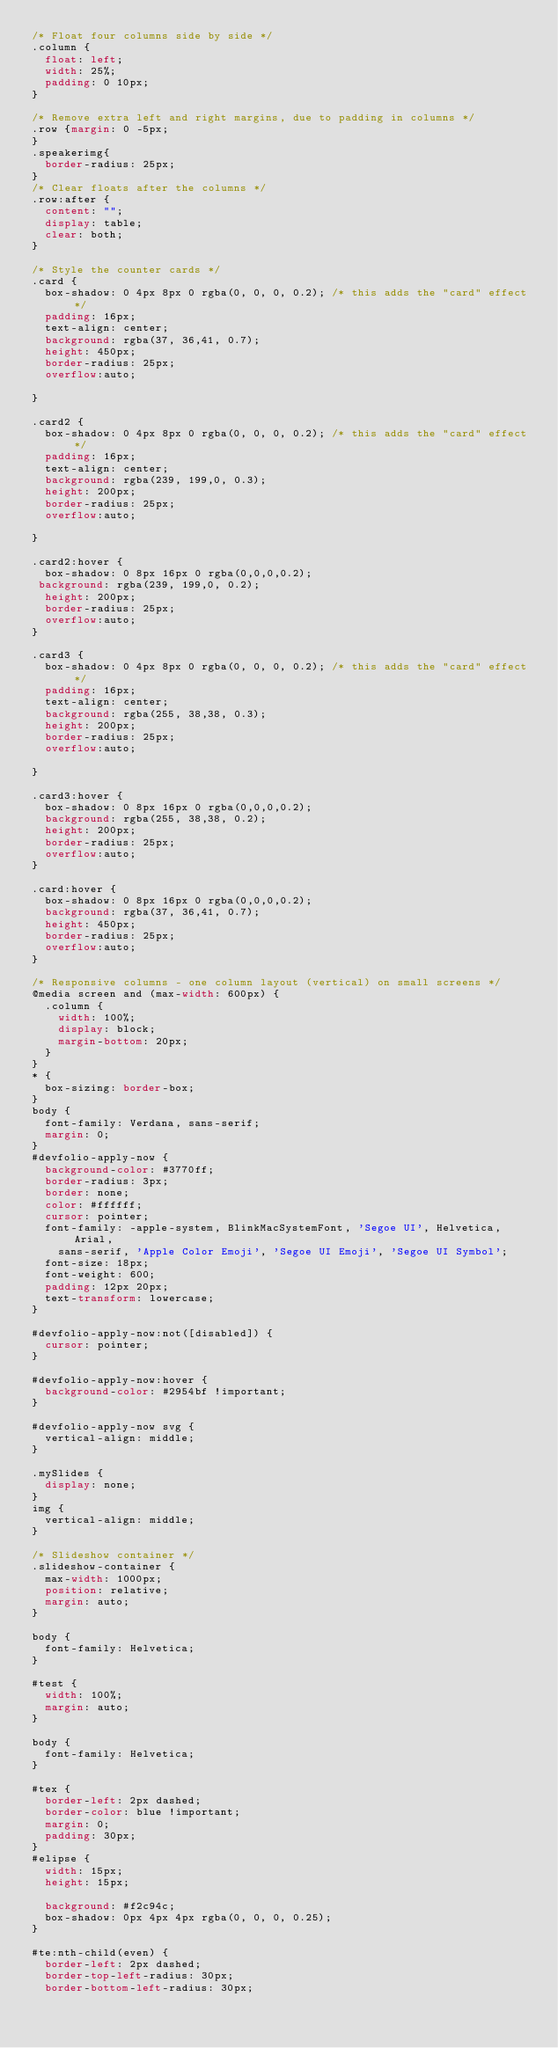Convert code to text. <code><loc_0><loc_0><loc_500><loc_500><_CSS_>/* Float four columns side by side */
.column {
  float: left;
  width: 25%;
  padding: 0 10px;
}

/* Remove extra left and right margins, due to padding in columns */
.row {margin: 0 -5px;
}
.speakerimg{
	border-radius: 25px;
}
/* Clear floats after the columns */
.row:after {
  content: "";
  display: table;
  clear: both;
}

/* Style the counter cards */
.card {
  box-shadow: 0 4px 8px 0 rgba(0, 0, 0, 0.2); /* this adds the "card" effect */
  padding: 16px;
  text-align: center;
  background: rgba(37, 36,41, 0.7);
  height: 450px;
  border-radius: 25px;
  overflow:auto;

}

.card2 {
  box-shadow: 0 4px 8px 0 rgba(0, 0, 0, 0.2); /* this adds the "card" effect */
  padding: 16px;
  text-align: center;
  background: rgba(239, 199,0, 0.3);
  height: 200px;
  border-radius: 25px;
  overflow:auto;

}

.card2:hover {
  box-shadow: 0 8px 16px 0 rgba(0,0,0,0.2);
 background: rgba(239, 199,0, 0.2);
  height: 200px;
  border-radius: 25px;
  overflow:auto;
}

.card3 {
  box-shadow: 0 4px 8px 0 rgba(0, 0, 0, 0.2); /* this adds the "card" effect */
  padding: 16px;
  text-align: center;
  background: rgba(255, 38,38, 0.3);
  height: 200px;
  border-radius: 25px;
  overflow:auto;

}

.card3:hover {
  box-shadow: 0 8px 16px 0 rgba(0,0,0,0.2);
  background: rgba(255, 38,38, 0.2);
  height: 200px;
  border-radius: 25px;
  overflow:auto;
}

.card:hover {
  box-shadow: 0 8px 16px 0 rgba(0,0,0,0.2);
  background: rgba(37, 36,41, 0.7);
  height: 450px;
  border-radius: 25px;
  overflow:auto;
}

/* Responsive columns - one column layout (vertical) on small screens */
@media screen and (max-width: 600px) {
  .column {
    width: 100%;
    display: block;
    margin-bottom: 20px;
  }
}
* {
	box-sizing: border-box;
}
body {
	font-family: Verdana, sans-serif;
	margin: 0;
}
#devfolio-apply-now {
	background-color: #3770ff;
	border-radius: 3px;
	border: none;
	color: #ffffff;
	cursor: pointer;
	font-family: -apple-system, BlinkMacSystemFont, 'Segoe UI', Helvetica, Arial,
		sans-serif, 'Apple Color Emoji', 'Segoe UI Emoji', 'Segoe UI Symbol';
	font-size: 18px;
	font-weight: 600;
	padding: 12px 20px;
	text-transform: lowercase;
}

#devfolio-apply-now:not([disabled]) {
	cursor: pointer;
}

#devfolio-apply-now:hover {
	background-color: #2954bf !important;
}

#devfolio-apply-now svg {
	vertical-align: middle;
}

.mySlides {
	display: none;
}
img {
	vertical-align: middle;
}

/* Slideshow container */
.slideshow-container {
	max-width: 1000px;
	position: relative;
	margin: auto;
}

body {
	font-family: Helvetica;
}

#test {
	width: 100%;
	margin: auto;
}

body {
	font-family: Helvetica;
}

#tex {
	border-left: 2px dashed;
	border-color: blue !important;
	margin: 0;
	padding: 30px;
}
#elipse {
	width: 15px;
	height: 15px;

	background: #f2c94c;
	box-shadow: 0px 4px 4px rgba(0, 0, 0, 0.25);
}

#te:nth-child(even) {
	border-left: 2px dashed;
	border-top-left-radius: 30px;
	border-bottom-left-radius: 30px;</code> 